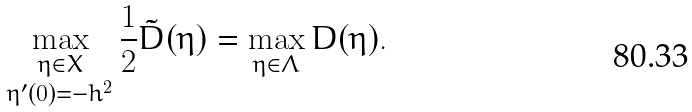Convert formula to latex. <formula><loc_0><loc_0><loc_500><loc_500>\max _ { \substack { \eta \in X \\ \eta ^ { \prime } ( 0 ) = - h ^ { 2 } } } \frac { 1 } { 2 } \tilde { D } ( \eta ) = \max _ { \eta \in \Lambda } D ( \eta ) .</formula> 